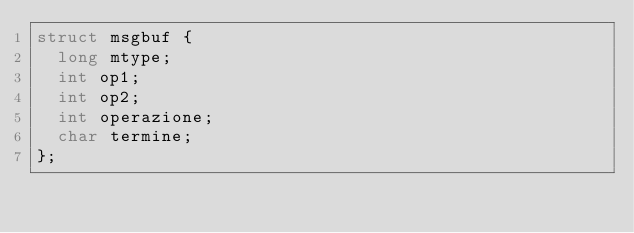<code> <loc_0><loc_0><loc_500><loc_500><_C_>struct msgbuf {
	long mtype;
	int op1;
	int op2;
	int operazione;
	char termine;
};</code> 